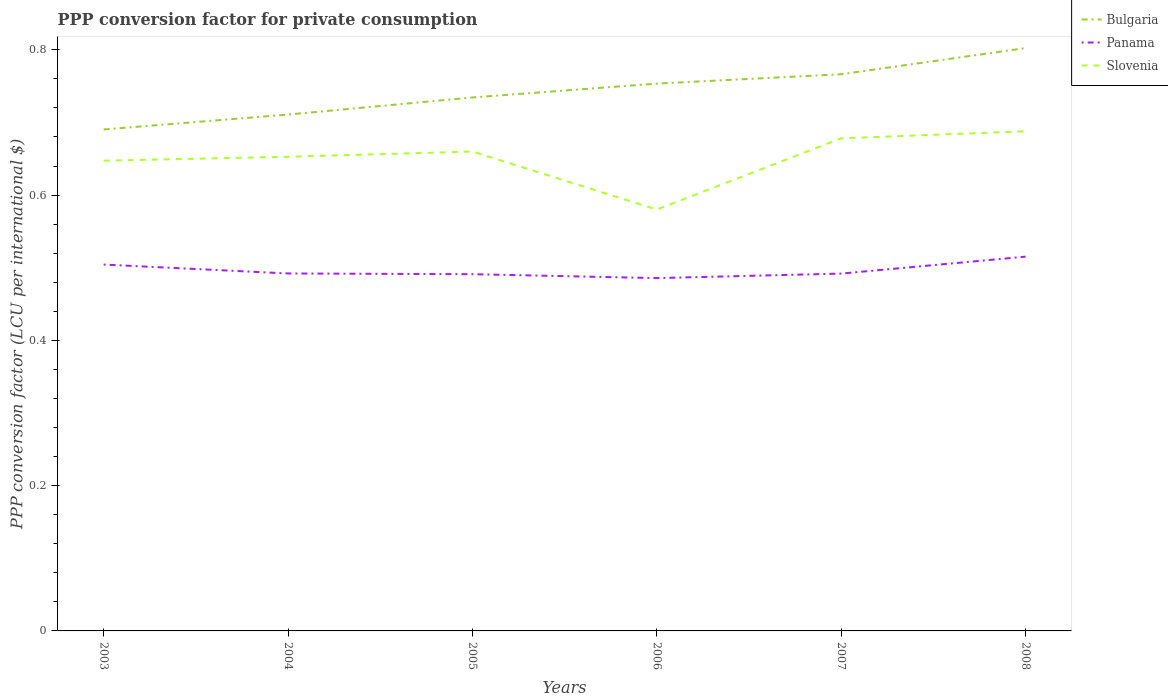How many different coloured lines are there?
Ensure brevity in your answer.  3. Does the line corresponding to Slovenia intersect with the line corresponding to Bulgaria?
Ensure brevity in your answer.  No. Across all years, what is the maximum PPP conversion factor for private consumption in Panama?
Offer a very short reply. 0.49. What is the total PPP conversion factor for private consumption in Panama in the graph?
Your answer should be very brief. -0.03. What is the difference between the highest and the second highest PPP conversion factor for private consumption in Panama?
Provide a short and direct response. 0.03. How many lines are there?
Give a very brief answer. 3. What is the difference between two consecutive major ticks on the Y-axis?
Offer a terse response. 0.2. Does the graph contain any zero values?
Provide a short and direct response. No. Where does the legend appear in the graph?
Offer a terse response. Top right. How many legend labels are there?
Your answer should be compact. 3. What is the title of the graph?
Your response must be concise. PPP conversion factor for private consumption. Does "Zimbabwe" appear as one of the legend labels in the graph?
Keep it short and to the point. No. What is the label or title of the Y-axis?
Give a very brief answer. PPP conversion factor (LCU per international $). What is the PPP conversion factor (LCU per international $) of Bulgaria in 2003?
Your response must be concise. 0.69. What is the PPP conversion factor (LCU per international $) of Panama in 2003?
Give a very brief answer. 0.5. What is the PPP conversion factor (LCU per international $) of Slovenia in 2003?
Provide a succinct answer. 0.65. What is the PPP conversion factor (LCU per international $) in Bulgaria in 2004?
Your answer should be very brief. 0.71. What is the PPP conversion factor (LCU per international $) in Panama in 2004?
Offer a terse response. 0.49. What is the PPP conversion factor (LCU per international $) in Slovenia in 2004?
Provide a succinct answer. 0.65. What is the PPP conversion factor (LCU per international $) of Bulgaria in 2005?
Keep it short and to the point. 0.73. What is the PPP conversion factor (LCU per international $) in Panama in 2005?
Offer a terse response. 0.49. What is the PPP conversion factor (LCU per international $) in Slovenia in 2005?
Ensure brevity in your answer.  0.66. What is the PPP conversion factor (LCU per international $) in Bulgaria in 2006?
Offer a very short reply. 0.75. What is the PPP conversion factor (LCU per international $) of Panama in 2006?
Offer a very short reply. 0.49. What is the PPP conversion factor (LCU per international $) in Slovenia in 2006?
Your answer should be very brief. 0.58. What is the PPP conversion factor (LCU per international $) in Bulgaria in 2007?
Provide a short and direct response. 0.77. What is the PPP conversion factor (LCU per international $) in Panama in 2007?
Provide a short and direct response. 0.49. What is the PPP conversion factor (LCU per international $) in Slovenia in 2007?
Give a very brief answer. 0.68. What is the PPP conversion factor (LCU per international $) in Bulgaria in 2008?
Provide a short and direct response. 0.8. What is the PPP conversion factor (LCU per international $) in Panama in 2008?
Provide a succinct answer. 0.52. What is the PPP conversion factor (LCU per international $) of Slovenia in 2008?
Your answer should be very brief. 0.69. Across all years, what is the maximum PPP conversion factor (LCU per international $) of Bulgaria?
Your response must be concise. 0.8. Across all years, what is the maximum PPP conversion factor (LCU per international $) of Panama?
Offer a terse response. 0.52. Across all years, what is the maximum PPP conversion factor (LCU per international $) in Slovenia?
Your response must be concise. 0.69. Across all years, what is the minimum PPP conversion factor (LCU per international $) of Bulgaria?
Offer a terse response. 0.69. Across all years, what is the minimum PPP conversion factor (LCU per international $) of Panama?
Keep it short and to the point. 0.49. Across all years, what is the minimum PPP conversion factor (LCU per international $) of Slovenia?
Ensure brevity in your answer.  0.58. What is the total PPP conversion factor (LCU per international $) of Bulgaria in the graph?
Give a very brief answer. 4.46. What is the total PPP conversion factor (LCU per international $) of Panama in the graph?
Ensure brevity in your answer.  2.98. What is the total PPP conversion factor (LCU per international $) in Slovenia in the graph?
Your response must be concise. 3.91. What is the difference between the PPP conversion factor (LCU per international $) of Bulgaria in 2003 and that in 2004?
Give a very brief answer. -0.02. What is the difference between the PPP conversion factor (LCU per international $) in Panama in 2003 and that in 2004?
Ensure brevity in your answer.  0.01. What is the difference between the PPP conversion factor (LCU per international $) of Slovenia in 2003 and that in 2004?
Your response must be concise. -0.01. What is the difference between the PPP conversion factor (LCU per international $) in Bulgaria in 2003 and that in 2005?
Ensure brevity in your answer.  -0.04. What is the difference between the PPP conversion factor (LCU per international $) of Panama in 2003 and that in 2005?
Offer a terse response. 0.01. What is the difference between the PPP conversion factor (LCU per international $) of Slovenia in 2003 and that in 2005?
Your answer should be very brief. -0.01. What is the difference between the PPP conversion factor (LCU per international $) of Bulgaria in 2003 and that in 2006?
Provide a short and direct response. -0.06. What is the difference between the PPP conversion factor (LCU per international $) in Panama in 2003 and that in 2006?
Provide a short and direct response. 0.02. What is the difference between the PPP conversion factor (LCU per international $) of Slovenia in 2003 and that in 2006?
Offer a very short reply. 0.07. What is the difference between the PPP conversion factor (LCU per international $) in Bulgaria in 2003 and that in 2007?
Make the answer very short. -0.08. What is the difference between the PPP conversion factor (LCU per international $) of Panama in 2003 and that in 2007?
Provide a short and direct response. 0.01. What is the difference between the PPP conversion factor (LCU per international $) in Slovenia in 2003 and that in 2007?
Give a very brief answer. -0.03. What is the difference between the PPP conversion factor (LCU per international $) in Bulgaria in 2003 and that in 2008?
Give a very brief answer. -0.11. What is the difference between the PPP conversion factor (LCU per international $) of Panama in 2003 and that in 2008?
Provide a succinct answer. -0.01. What is the difference between the PPP conversion factor (LCU per international $) of Slovenia in 2003 and that in 2008?
Give a very brief answer. -0.04. What is the difference between the PPP conversion factor (LCU per international $) in Bulgaria in 2004 and that in 2005?
Provide a succinct answer. -0.02. What is the difference between the PPP conversion factor (LCU per international $) of Panama in 2004 and that in 2005?
Offer a very short reply. 0. What is the difference between the PPP conversion factor (LCU per international $) in Slovenia in 2004 and that in 2005?
Provide a succinct answer. -0.01. What is the difference between the PPP conversion factor (LCU per international $) of Bulgaria in 2004 and that in 2006?
Give a very brief answer. -0.04. What is the difference between the PPP conversion factor (LCU per international $) of Panama in 2004 and that in 2006?
Provide a short and direct response. 0.01. What is the difference between the PPP conversion factor (LCU per international $) in Slovenia in 2004 and that in 2006?
Keep it short and to the point. 0.07. What is the difference between the PPP conversion factor (LCU per international $) of Bulgaria in 2004 and that in 2007?
Your response must be concise. -0.06. What is the difference between the PPP conversion factor (LCU per international $) in Panama in 2004 and that in 2007?
Provide a succinct answer. 0. What is the difference between the PPP conversion factor (LCU per international $) in Slovenia in 2004 and that in 2007?
Offer a terse response. -0.03. What is the difference between the PPP conversion factor (LCU per international $) in Bulgaria in 2004 and that in 2008?
Keep it short and to the point. -0.09. What is the difference between the PPP conversion factor (LCU per international $) of Panama in 2004 and that in 2008?
Provide a succinct answer. -0.02. What is the difference between the PPP conversion factor (LCU per international $) of Slovenia in 2004 and that in 2008?
Provide a succinct answer. -0.04. What is the difference between the PPP conversion factor (LCU per international $) in Bulgaria in 2005 and that in 2006?
Offer a terse response. -0.02. What is the difference between the PPP conversion factor (LCU per international $) in Panama in 2005 and that in 2006?
Provide a succinct answer. 0.01. What is the difference between the PPP conversion factor (LCU per international $) in Slovenia in 2005 and that in 2006?
Your answer should be compact. 0.08. What is the difference between the PPP conversion factor (LCU per international $) in Bulgaria in 2005 and that in 2007?
Keep it short and to the point. -0.03. What is the difference between the PPP conversion factor (LCU per international $) in Panama in 2005 and that in 2007?
Keep it short and to the point. -0. What is the difference between the PPP conversion factor (LCU per international $) in Slovenia in 2005 and that in 2007?
Make the answer very short. -0.02. What is the difference between the PPP conversion factor (LCU per international $) of Bulgaria in 2005 and that in 2008?
Keep it short and to the point. -0.07. What is the difference between the PPP conversion factor (LCU per international $) in Panama in 2005 and that in 2008?
Ensure brevity in your answer.  -0.02. What is the difference between the PPP conversion factor (LCU per international $) in Slovenia in 2005 and that in 2008?
Provide a succinct answer. -0.03. What is the difference between the PPP conversion factor (LCU per international $) in Bulgaria in 2006 and that in 2007?
Provide a succinct answer. -0.01. What is the difference between the PPP conversion factor (LCU per international $) of Panama in 2006 and that in 2007?
Keep it short and to the point. -0.01. What is the difference between the PPP conversion factor (LCU per international $) of Slovenia in 2006 and that in 2007?
Your response must be concise. -0.1. What is the difference between the PPP conversion factor (LCU per international $) of Bulgaria in 2006 and that in 2008?
Make the answer very short. -0.05. What is the difference between the PPP conversion factor (LCU per international $) in Panama in 2006 and that in 2008?
Provide a short and direct response. -0.03. What is the difference between the PPP conversion factor (LCU per international $) in Slovenia in 2006 and that in 2008?
Offer a terse response. -0.11. What is the difference between the PPP conversion factor (LCU per international $) in Bulgaria in 2007 and that in 2008?
Keep it short and to the point. -0.04. What is the difference between the PPP conversion factor (LCU per international $) in Panama in 2007 and that in 2008?
Offer a terse response. -0.02. What is the difference between the PPP conversion factor (LCU per international $) of Slovenia in 2007 and that in 2008?
Ensure brevity in your answer.  -0.01. What is the difference between the PPP conversion factor (LCU per international $) of Bulgaria in 2003 and the PPP conversion factor (LCU per international $) of Panama in 2004?
Give a very brief answer. 0.2. What is the difference between the PPP conversion factor (LCU per international $) in Bulgaria in 2003 and the PPP conversion factor (LCU per international $) in Slovenia in 2004?
Give a very brief answer. 0.04. What is the difference between the PPP conversion factor (LCU per international $) of Panama in 2003 and the PPP conversion factor (LCU per international $) of Slovenia in 2004?
Give a very brief answer. -0.15. What is the difference between the PPP conversion factor (LCU per international $) of Bulgaria in 2003 and the PPP conversion factor (LCU per international $) of Panama in 2005?
Give a very brief answer. 0.2. What is the difference between the PPP conversion factor (LCU per international $) of Bulgaria in 2003 and the PPP conversion factor (LCU per international $) of Slovenia in 2005?
Give a very brief answer. 0.03. What is the difference between the PPP conversion factor (LCU per international $) in Panama in 2003 and the PPP conversion factor (LCU per international $) in Slovenia in 2005?
Offer a terse response. -0.16. What is the difference between the PPP conversion factor (LCU per international $) of Bulgaria in 2003 and the PPP conversion factor (LCU per international $) of Panama in 2006?
Offer a very short reply. 0.2. What is the difference between the PPP conversion factor (LCU per international $) of Bulgaria in 2003 and the PPP conversion factor (LCU per international $) of Slovenia in 2006?
Your response must be concise. 0.11. What is the difference between the PPP conversion factor (LCU per international $) in Panama in 2003 and the PPP conversion factor (LCU per international $) in Slovenia in 2006?
Provide a short and direct response. -0.08. What is the difference between the PPP conversion factor (LCU per international $) of Bulgaria in 2003 and the PPP conversion factor (LCU per international $) of Panama in 2007?
Make the answer very short. 0.2. What is the difference between the PPP conversion factor (LCU per international $) of Bulgaria in 2003 and the PPP conversion factor (LCU per international $) of Slovenia in 2007?
Ensure brevity in your answer.  0.01. What is the difference between the PPP conversion factor (LCU per international $) of Panama in 2003 and the PPP conversion factor (LCU per international $) of Slovenia in 2007?
Your answer should be very brief. -0.17. What is the difference between the PPP conversion factor (LCU per international $) of Bulgaria in 2003 and the PPP conversion factor (LCU per international $) of Panama in 2008?
Provide a short and direct response. 0.18. What is the difference between the PPP conversion factor (LCU per international $) in Bulgaria in 2003 and the PPP conversion factor (LCU per international $) in Slovenia in 2008?
Ensure brevity in your answer.  0. What is the difference between the PPP conversion factor (LCU per international $) of Panama in 2003 and the PPP conversion factor (LCU per international $) of Slovenia in 2008?
Make the answer very short. -0.18. What is the difference between the PPP conversion factor (LCU per international $) of Bulgaria in 2004 and the PPP conversion factor (LCU per international $) of Panama in 2005?
Make the answer very short. 0.22. What is the difference between the PPP conversion factor (LCU per international $) in Bulgaria in 2004 and the PPP conversion factor (LCU per international $) in Slovenia in 2005?
Your answer should be very brief. 0.05. What is the difference between the PPP conversion factor (LCU per international $) of Panama in 2004 and the PPP conversion factor (LCU per international $) of Slovenia in 2005?
Your answer should be compact. -0.17. What is the difference between the PPP conversion factor (LCU per international $) of Bulgaria in 2004 and the PPP conversion factor (LCU per international $) of Panama in 2006?
Provide a succinct answer. 0.23. What is the difference between the PPP conversion factor (LCU per international $) in Bulgaria in 2004 and the PPP conversion factor (LCU per international $) in Slovenia in 2006?
Make the answer very short. 0.13. What is the difference between the PPP conversion factor (LCU per international $) of Panama in 2004 and the PPP conversion factor (LCU per international $) of Slovenia in 2006?
Offer a very short reply. -0.09. What is the difference between the PPP conversion factor (LCU per international $) in Bulgaria in 2004 and the PPP conversion factor (LCU per international $) in Panama in 2007?
Give a very brief answer. 0.22. What is the difference between the PPP conversion factor (LCU per international $) in Bulgaria in 2004 and the PPP conversion factor (LCU per international $) in Slovenia in 2007?
Ensure brevity in your answer.  0.03. What is the difference between the PPP conversion factor (LCU per international $) of Panama in 2004 and the PPP conversion factor (LCU per international $) of Slovenia in 2007?
Provide a succinct answer. -0.19. What is the difference between the PPP conversion factor (LCU per international $) in Bulgaria in 2004 and the PPP conversion factor (LCU per international $) in Panama in 2008?
Offer a very short reply. 0.2. What is the difference between the PPP conversion factor (LCU per international $) in Bulgaria in 2004 and the PPP conversion factor (LCU per international $) in Slovenia in 2008?
Your answer should be very brief. 0.02. What is the difference between the PPP conversion factor (LCU per international $) of Panama in 2004 and the PPP conversion factor (LCU per international $) of Slovenia in 2008?
Keep it short and to the point. -0.2. What is the difference between the PPP conversion factor (LCU per international $) of Bulgaria in 2005 and the PPP conversion factor (LCU per international $) of Panama in 2006?
Give a very brief answer. 0.25. What is the difference between the PPP conversion factor (LCU per international $) in Bulgaria in 2005 and the PPP conversion factor (LCU per international $) in Slovenia in 2006?
Your answer should be very brief. 0.15. What is the difference between the PPP conversion factor (LCU per international $) in Panama in 2005 and the PPP conversion factor (LCU per international $) in Slovenia in 2006?
Your response must be concise. -0.09. What is the difference between the PPP conversion factor (LCU per international $) of Bulgaria in 2005 and the PPP conversion factor (LCU per international $) of Panama in 2007?
Make the answer very short. 0.24. What is the difference between the PPP conversion factor (LCU per international $) in Bulgaria in 2005 and the PPP conversion factor (LCU per international $) in Slovenia in 2007?
Provide a short and direct response. 0.06. What is the difference between the PPP conversion factor (LCU per international $) in Panama in 2005 and the PPP conversion factor (LCU per international $) in Slovenia in 2007?
Make the answer very short. -0.19. What is the difference between the PPP conversion factor (LCU per international $) of Bulgaria in 2005 and the PPP conversion factor (LCU per international $) of Panama in 2008?
Your answer should be very brief. 0.22. What is the difference between the PPP conversion factor (LCU per international $) of Bulgaria in 2005 and the PPP conversion factor (LCU per international $) of Slovenia in 2008?
Ensure brevity in your answer.  0.05. What is the difference between the PPP conversion factor (LCU per international $) of Panama in 2005 and the PPP conversion factor (LCU per international $) of Slovenia in 2008?
Your response must be concise. -0.2. What is the difference between the PPP conversion factor (LCU per international $) of Bulgaria in 2006 and the PPP conversion factor (LCU per international $) of Panama in 2007?
Your answer should be compact. 0.26. What is the difference between the PPP conversion factor (LCU per international $) of Bulgaria in 2006 and the PPP conversion factor (LCU per international $) of Slovenia in 2007?
Your response must be concise. 0.08. What is the difference between the PPP conversion factor (LCU per international $) in Panama in 2006 and the PPP conversion factor (LCU per international $) in Slovenia in 2007?
Ensure brevity in your answer.  -0.19. What is the difference between the PPP conversion factor (LCU per international $) in Bulgaria in 2006 and the PPP conversion factor (LCU per international $) in Panama in 2008?
Make the answer very short. 0.24. What is the difference between the PPP conversion factor (LCU per international $) of Bulgaria in 2006 and the PPP conversion factor (LCU per international $) of Slovenia in 2008?
Keep it short and to the point. 0.07. What is the difference between the PPP conversion factor (LCU per international $) in Panama in 2006 and the PPP conversion factor (LCU per international $) in Slovenia in 2008?
Offer a very short reply. -0.2. What is the difference between the PPP conversion factor (LCU per international $) in Bulgaria in 2007 and the PPP conversion factor (LCU per international $) in Panama in 2008?
Make the answer very short. 0.25. What is the difference between the PPP conversion factor (LCU per international $) of Bulgaria in 2007 and the PPP conversion factor (LCU per international $) of Slovenia in 2008?
Make the answer very short. 0.08. What is the difference between the PPP conversion factor (LCU per international $) in Panama in 2007 and the PPP conversion factor (LCU per international $) in Slovenia in 2008?
Provide a succinct answer. -0.2. What is the average PPP conversion factor (LCU per international $) of Bulgaria per year?
Your response must be concise. 0.74. What is the average PPP conversion factor (LCU per international $) in Panama per year?
Offer a terse response. 0.5. What is the average PPP conversion factor (LCU per international $) of Slovenia per year?
Provide a succinct answer. 0.65. In the year 2003, what is the difference between the PPP conversion factor (LCU per international $) of Bulgaria and PPP conversion factor (LCU per international $) of Panama?
Offer a terse response. 0.19. In the year 2003, what is the difference between the PPP conversion factor (LCU per international $) in Bulgaria and PPP conversion factor (LCU per international $) in Slovenia?
Your answer should be very brief. 0.04. In the year 2003, what is the difference between the PPP conversion factor (LCU per international $) in Panama and PPP conversion factor (LCU per international $) in Slovenia?
Ensure brevity in your answer.  -0.14. In the year 2004, what is the difference between the PPP conversion factor (LCU per international $) of Bulgaria and PPP conversion factor (LCU per international $) of Panama?
Offer a terse response. 0.22. In the year 2004, what is the difference between the PPP conversion factor (LCU per international $) in Bulgaria and PPP conversion factor (LCU per international $) in Slovenia?
Give a very brief answer. 0.06. In the year 2004, what is the difference between the PPP conversion factor (LCU per international $) of Panama and PPP conversion factor (LCU per international $) of Slovenia?
Your answer should be compact. -0.16. In the year 2005, what is the difference between the PPP conversion factor (LCU per international $) of Bulgaria and PPP conversion factor (LCU per international $) of Panama?
Provide a short and direct response. 0.24. In the year 2005, what is the difference between the PPP conversion factor (LCU per international $) in Bulgaria and PPP conversion factor (LCU per international $) in Slovenia?
Provide a succinct answer. 0.07. In the year 2005, what is the difference between the PPP conversion factor (LCU per international $) of Panama and PPP conversion factor (LCU per international $) of Slovenia?
Your answer should be compact. -0.17. In the year 2006, what is the difference between the PPP conversion factor (LCU per international $) of Bulgaria and PPP conversion factor (LCU per international $) of Panama?
Your answer should be compact. 0.27. In the year 2006, what is the difference between the PPP conversion factor (LCU per international $) in Bulgaria and PPP conversion factor (LCU per international $) in Slovenia?
Your answer should be compact. 0.17. In the year 2006, what is the difference between the PPP conversion factor (LCU per international $) in Panama and PPP conversion factor (LCU per international $) in Slovenia?
Make the answer very short. -0.09. In the year 2007, what is the difference between the PPP conversion factor (LCU per international $) in Bulgaria and PPP conversion factor (LCU per international $) in Panama?
Give a very brief answer. 0.27. In the year 2007, what is the difference between the PPP conversion factor (LCU per international $) of Bulgaria and PPP conversion factor (LCU per international $) of Slovenia?
Provide a short and direct response. 0.09. In the year 2007, what is the difference between the PPP conversion factor (LCU per international $) of Panama and PPP conversion factor (LCU per international $) of Slovenia?
Ensure brevity in your answer.  -0.19. In the year 2008, what is the difference between the PPP conversion factor (LCU per international $) of Bulgaria and PPP conversion factor (LCU per international $) of Panama?
Your answer should be very brief. 0.29. In the year 2008, what is the difference between the PPP conversion factor (LCU per international $) of Bulgaria and PPP conversion factor (LCU per international $) of Slovenia?
Your response must be concise. 0.11. In the year 2008, what is the difference between the PPP conversion factor (LCU per international $) in Panama and PPP conversion factor (LCU per international $) in Slovenia?
Provide a succinct answer. -0.17. What is the ratio of the PPP conversion factor (LCU per international $) in Bulgaria in 2003 to that in 2004?
Provide a short and direct response. 0.97. What is the ratio of the PPP conversion factor (LCU per international $) of Panama in 2003 to that in 2004?
Provide a succinct answer. 1.02. What is the ratio of the PPP conversion factor (LCU per international $) of Slovenia in 2003 to that in 2004?
Offer a terse response. 0.99. What is the ratio of the PPP conversion factor (LCU per international $) in Panama in 2003 to that in 2005?
Your answer should be very brief. 1.03. What is the ratio of the PPP conversion factor (LCU per international $) of Slovenia in 2003 to that in 2005?
Provide a short and direct response. 0.98. What is the ratio of the PPP conversion factor (LCU per international $) in Bulgaria in 2003 to that in 2006?
Offer a terse response. 0.92. What is the ratio of the PPP conversion factor (LCU per international $) of Panama in 2003 to that in 2006?
Provide a short and direct response. 1.04. What is the ratio of the PPP conversion factor (LCU per international $) of Slovenia in 2003 to that in 2006?
Ensure brevity in your answer.  1.12. What is the ratio of the PPP conversion factor (LCU per international $) in Bulgaria in 2003 to that in 2007?
Keep it short and to the point. 0.9. What is the ratio of the PPP conversion factor (LCU per international $) of Panama in 2003 to that in 2007?
Provide a succinct answer. 1.03. What is the ratio of the PPP conversion factor (LCU per international $) in Slovenia in 2003 to that in 2007?
Make the answer very short. 0.95. What is the ratio of the PPP conversion factor (LCU per international $) of Bulgaria in 2003 to that in 2008?
Offer a terse response. 0.86. What is the ratio of the PPP conversion factor (LCU per international $) in Panama in 2003 to that in 2008?
Keep it short and to the point. 0.98. What is the ratio of the PPP conversion factor (LCU per international $) in Slovenia in 2003 to that in 2008?
Offer a terse response. 0.94. What is the ratio of the PPP conversion factor (LCU per international $) of Bulgaria in 2004 to that in 2005?
Provide a succinct answer. 0.97. What is the ratio of the PPP conversion factor (LCU per international $) of Panama in 2004 to that in 2005?
Make the answer very short. 1. What is the ratio of the PPP conversion factor (LCU per international $) of Bulgaria in 2004 to that in 2006?
Offer a terse response. 0.94. What is the ratio of the PPP conversion factor (LCU per international $) in Panama in 2004 to that in 2006?
Your answer should be very brief. 1.01. What is the ratio of the PPP conversion factor (LCU per international $) of Slovenia in 2004 to that in 2006?
Your answer should be very brief. 1.13. What is the ratio of the PPP conversion factor (LCU per international $) in Bulgaria in 2004 to that in 2007?
Provide a succinct answer. 0.93. What is the ratio of the PPP conversion factor (LCU per international $) of Slovenia in 2004 to that in 2007?
Your answer should be compact. 0.96. What is the ratio of the PPP conversion factor (LCU per international $) of Bulgaria in 2004 to that in 2008?
Keep it short and to the point. 0.89. What is the ratio of the PPP conversion factor (LCU per international $) of Panama in 2004 to that in 2008?
Provide a short and direct response. 0.96. What is the ratio of the PPP conversion factor (LCU per international $) in Slovenia in 2004 to that in 2008?
Provide a short and direct response. 0.95. What is the ratio of the PPP conversion factor (LCU per international $) in Bulgaria in 2005 to that in 2006?
Offer a very short reply. 0.97. What is the ratio of the PPP conversion factor (LCU per international $) in Panama in 2005 to that in 2006?
Ensure brevity in your answer.  1.01. What is the ratio of the PPP conversion factor (LCU per international $) in Slovenia in 2005 to that in 2006?
Your response must be concise. 1.14. What is the ratio of the PPP conversion factor (LCU per international $) in Slovenia in 2005 to that in 2007?
Keep it short and to the point. 0.97. What is the ratio of the PPP conversion factor (LCU per international $) in Bulgaria in 2005 to that in 2008?
Your answer should be compact. 0.92. What is the ratio of the PPP conversion factor (LCU per international $) in Panama in 2005 to that in 2008?
Your response must be concise. 0.95. What is the ratio of the PPP conversion factor (LCU per international $) in Slovenia in 2005 to that in 2008?
Ensure brevity in your answer.  0.96. What is the ratio of the PPP conversion factor (LCU per international $) in Bulgaria in 2006 to that in 2007?
Keep it short and to the point. 0.98. What is the ratio of the PPP conversion factor (LCU per international $) in Panama in 2006 to that in 2007?
Your response must be concise. 0.99. What is the ratio of the PPP conversion factor (LCU per international $) in Slovenia in 2006 to that in 2007?
Your answer should be very brief. 0.86. What is the ratio of the PPP conversion factor (LCU per international $) of Bulgaria in 2006 to that in 2008?
Provide a short and direct response. 0.94. What is the ratio of the PPP conversion factor (LCU per international $) of Panama in 2006 to that in 2008?
Offer a terse response. 0.94. What is the ratio of the PPP conversion factor (LCU per international $) in Slovenia in 2006 to that in 2008?
Offer a very short reply. 0.84. What is the ratio of the PPP conversion factor (LCU per international $) of Bulgaria in 2007 to that in 2008?
Your answer should be compact. 0.96. What is the ratio of the PPP conversion factor (LCU per international $) in Panama in 2007 to that in 2008?
Offer a terse response. 0.95. What is the ratio of the PPP conversion factor (LCU per international $) of Slovenia in 2007 to that in 2008?
Give a very brief answer. 0.99. What is the difference between the highest and the second highest PPP conversion factor (LCU per international $) of Bulgaria?
Provide a short and direct response. 0.04. What is the difference between the highest and the second highest PPP conversion factor (LCU per international $) of Panama?
Provide a succinct answer. 0.01. What is the difference between the highest and the second highest PPP conversion factor (LCU per international $) of Slovenia?
Give a very brief answer. 0.01. What is the difference between the highest and the lowest PPP conversion factor (LCU per international $) of Bulgaria?
Offer a very short reply. 0.11. What is the difference between the highest and the lowest PPP conversion factor (LCU per international $) in Panama?
Keep it short and to the point. 0.03. What is the difference between the highest and the lowest PPP conversion factor (LCU per international $) of Slovenia?
Make the answer very short. 0.11. 